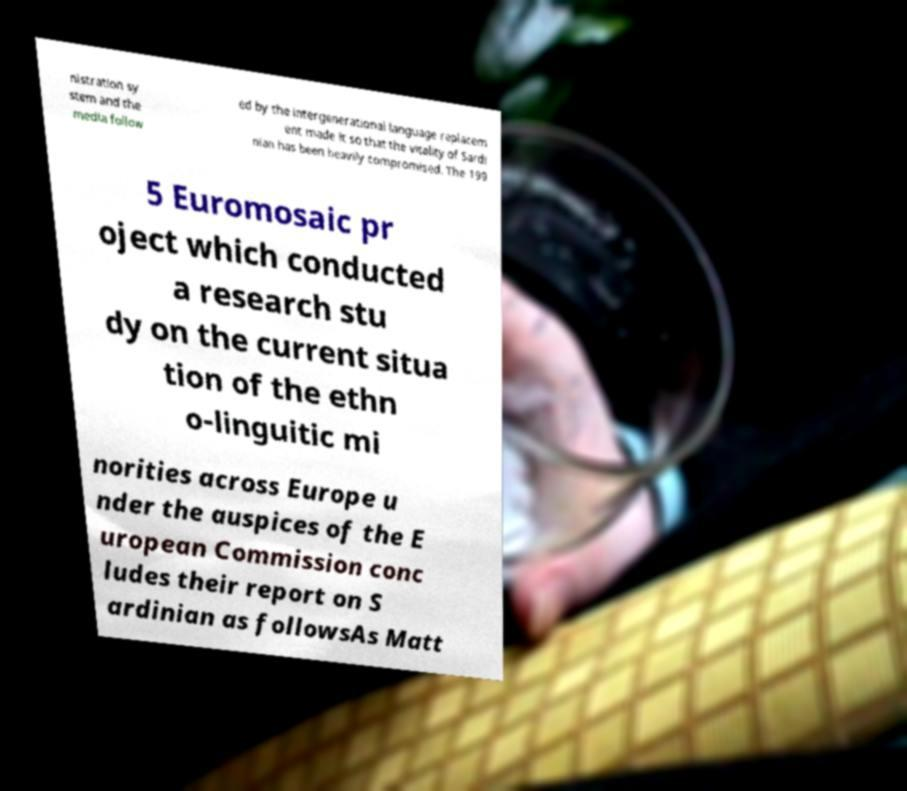I need the written content from this picture converted into text. Can you do that? nistration sy stem and the media follow ed by the intergenerational language replacem ent made it so that the vitality of Sardi nian has been heavily compromised. The 199 5 Euromosaic pr oject which conducted a research stu dy on the current situa tion of the ethn o-linguitic mi norities across Europe u nder the auspices of the E uropean Commission conc ludes their report on S ardinian as followsAs Matt 